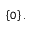Convert formula to latex. <formula><loc_0><loc_0><loc_500><loc_500>\left \{ 0 \right \} .</formula> 